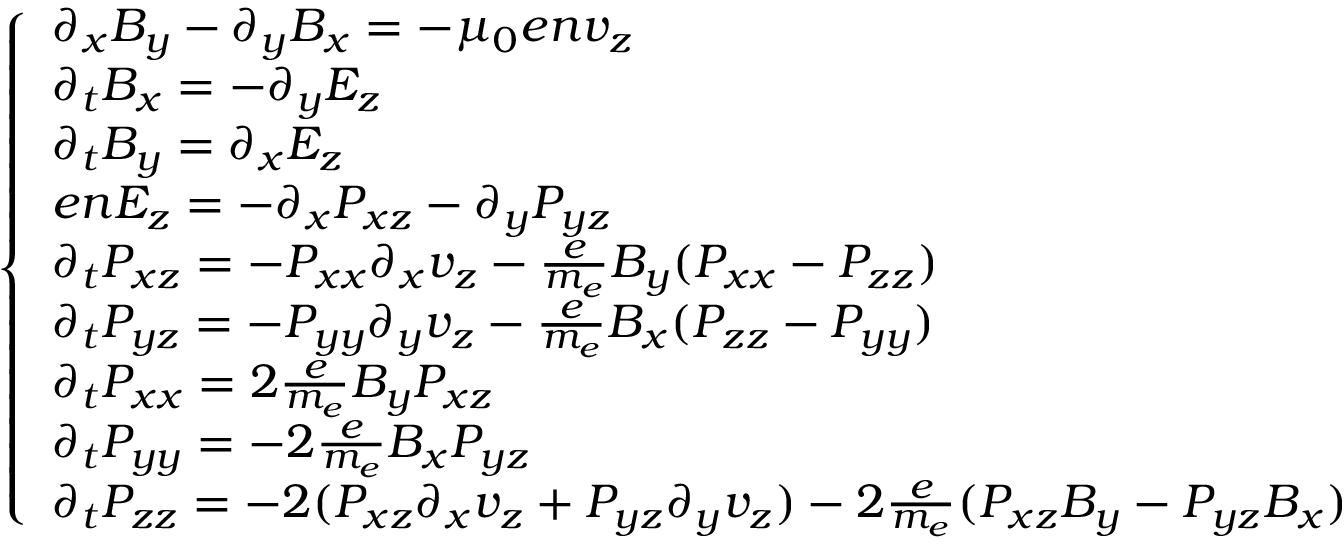<formula> <loc_0><loc_0><loc_500><loc_500>\begin{array} { r } { \left \{ \begin{array} { l l } { \partial _ { x } B _ { y } - \partial _ { y } B _ { x } = - \mu _ { 0 } e n v _ { z } } \\ { \partial _ { t } B _ { x } = - \partial _ { y } E _ { z } } \\ { \partial _ { t } B _ { y } = \partial _ { x } E _ { z } } \\ { e n E _ { z } = - \partial _ { x } P _ { x z } - \partial _ { y } P _ { y z } } \\ { \partial _ { t } P _ { x z } = - P _ { x x } \partial _ { x } v _ { z } - \frac { e } { m _ { e } } B _ { y } ( P _ { x x } - P _ { z z } ) } \\ { \partial _ { t } P _ { y z } = - P _ { y y } \partial _ { y } v _ { z } - \frac { e } { m _ { e } } B _ { x } ( P _ { z z } - P _ { y y } ) } \\ { \partial _ { t } P _ { x x } = 2 \frac { e } { m _ { e } } B _ { y } P _ { x z } } \\ { \partial _ { t } P _ { y y } = - 2 \frac { e } { m _ { e } } B _ { x } P _ { y z } } \\ { \partial _ { t } P _ { z z } = - 2 ( P _ { x z } \partial _ { x } v _ { z } + P _ { y z } \partial _ { y } v _ { z } ) - 2 \frac { e } { m _ { e } } ( P _ { x z } B _ { y } - P _ { y z } B _ { x } ) } \end{array} } \end{array}</formula> 